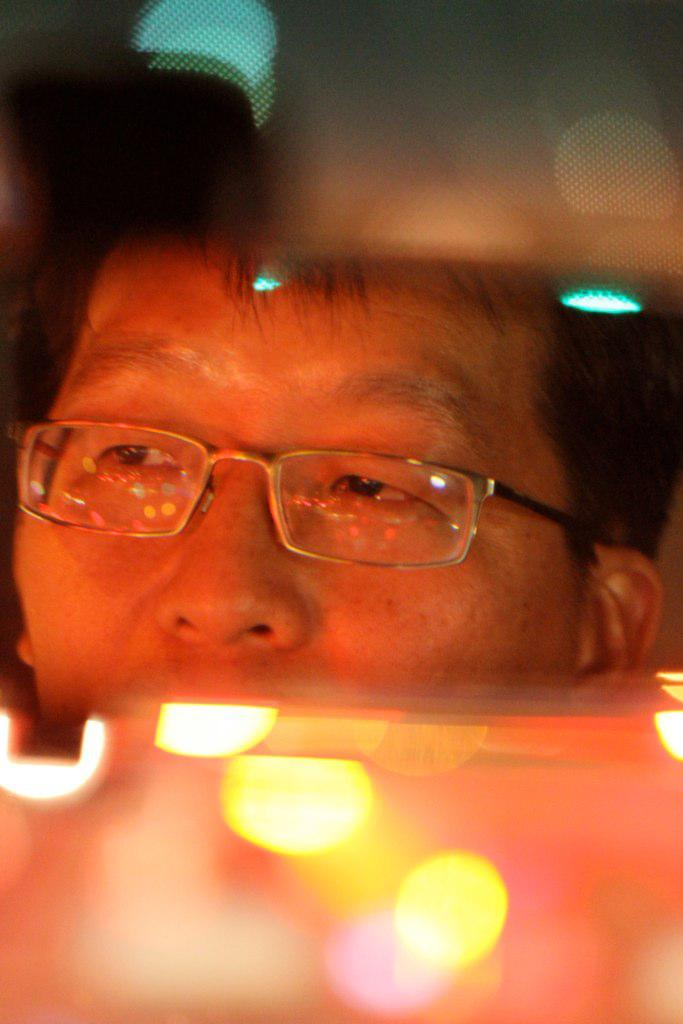What is the condition of the bottom and top of the image? The bottom and top of the image are blurry. What can be seen in the image besides the blurry areas? Lights are visible in the image. What is the reflection of in the middle of the image? There is a person's face reflection on a mirror in the middle of the image. What story is the thumb telling in the image? There is no thumb present in the image, and therefore no story can be told by it. 